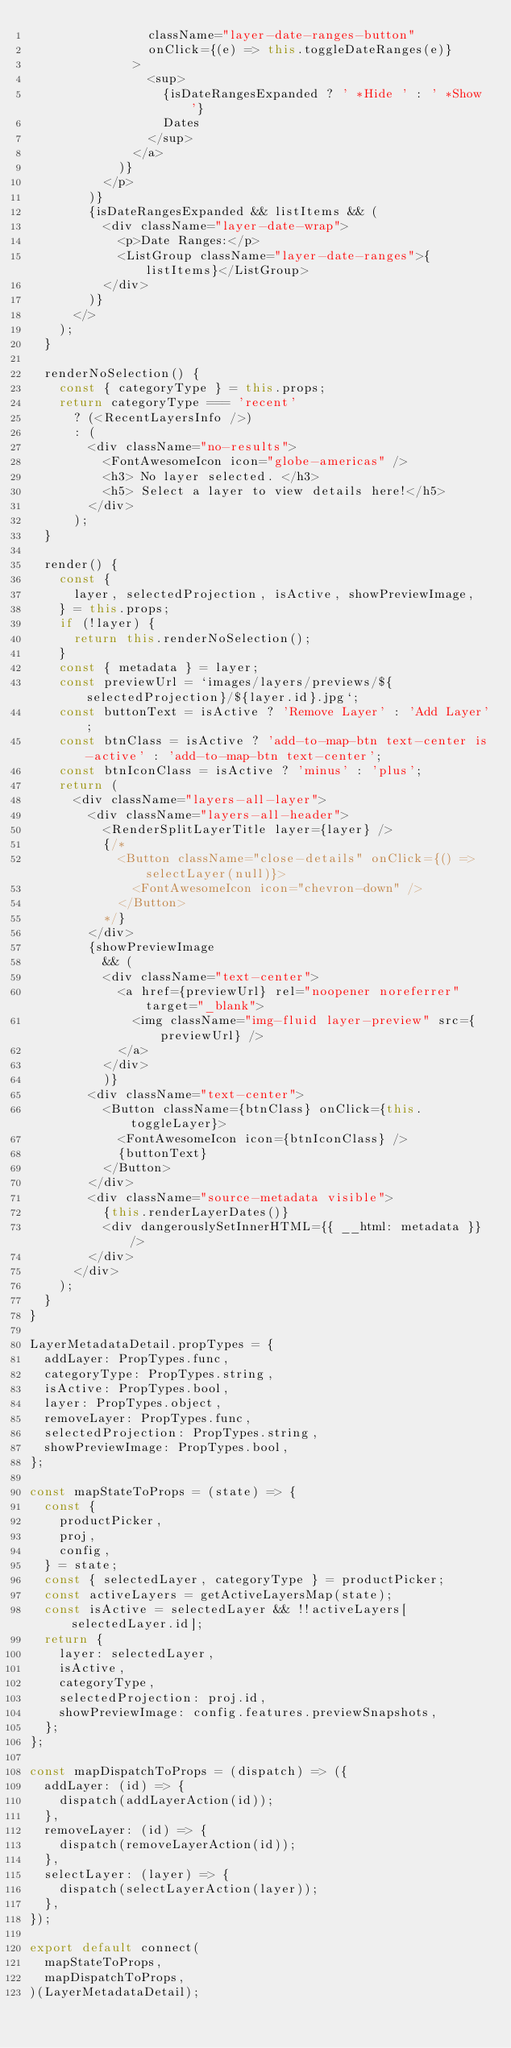Convert code to text. <code><loc_0><loc_0><loc_500><loc_500><_JavaScript_>                className="layer-date-ranges-button"
                onClick={(e) => this.toggleDateRanges(e)}
              >
                <sup>
                  {isDateRangesExpanded ? ' *Hide ' : ' *Show '}
                  Dates
                </sup>
              </a>
            )}
          </p>
        )}
        {isDateRangesExpanded && listItems && (
          <div className="layer-date-wrap">
            <p>Date Ranges:</p>
            <ListGroup className="layer-date-ranges">{listItems}</ListGroup>
          </div>
        )}
      </>
    );
  }

  renderNoSelection() {
    const { categoryType } = this.props;
    return categoryType === 'recent'
      ? (<RecentLayersInfo />)
      : (
        <div className="no-results">
          <FontAwesomeIcon icon="globe-americas" />
          <h3> No layer selected. </h3>
          <h5> Select a layer to view details here!</h5>
        </div>
      );
  }

  render() {
    const {
      layer, selectedProjection, isActive, showPreviewImage,
    } = this.props;
    if (!layer) {
      return this.renderNoSelection();
    }
    const { metadata } = layer;
    const previewUrl = `images/layers/previews/${selectedProjection}/${layer.id}.jpg`;
    const buttonText = isActive ? 'Remove Layer' : 'Add Layer';
    const btnClass = isActive ? 'add-to-map-btn text-center is-active' : 'add-to-map-btn text-center';
    const btnIconClass = isActive ? 'minus' : 'plus';
    return (
      <div className="layers-all-layer">
        <div className="layers-all-header">
          <RenderSplitLayerTitle layer={layer} />
          {/*
            <Button className="close-details" onClick={() => selectLayer(null)}>
              <FontAwesomeIcon icon="chevron-down" />
            </Button>
          */}
        </div>
        {showPreviewImage
          && (
          <div className="text-center">
            <a href={previewUrl} rel="noopener noreferrer" target="_blank">
              <img className="img-fluid layer-preview" src={previewUrl} />
            </a>
          </div>
          )}
        <div className="text-center">
          <Button className={btnClass} onClick={this.toggleLayer}>
            <FontAwesomeIcon icon={btnIconClass} />
            {buttonText}
          </Button>
        </div>
        <div className="source-metadata visible">
          {this.renderLayerDates()}
          <div dangerouslySetInnerHTML={{ __html: metadata }} />
        </div>
      </div>
    );
  }
}

LayerMetadataDetail.propTypes = {
  addLayer: PropTypes.func,
  categoryType: PropTypes.string,
  isActive: PropTypes.bool,
  layer: PropTypes.object,
  removeLayer: PropTypes.func,
  selectedProjection: PropTypes.string,
  showPreviewImage: PropTypes.bool,
};

const mapStateToProps = (state) => {
  const {
    productPicker,
    proj,
    config,
  } = state;
  const { selectedLayer, categoryType } = productPicker;
  const activeLayers = getActiveLayersMap(state);
  const isActive = selectedLayer && !!activeLayers[selectedLayer.id];
  return {
    layer: selectedLayer,
    isActive,
    categoryType,
    selectedProjection: proj.id,
    showPreviewImage: config.features.previewSnapshots,
  };
};

const mapDispatchToProps = (dispatch) => ({
  addLayer: (id) => {
    dispatch(addLayerAction(id));
  },
  removeLayer: (id) => {
    dispatch(removeLayerAction(id));
  },
  selectLayer: (layer) => {
    dispatch(selectLayerAction(layer));
  },
});

export default connect(
  mapStateToProps,
  mapDispatchToProps,
)(LayerMetadataDetail);
</code> 